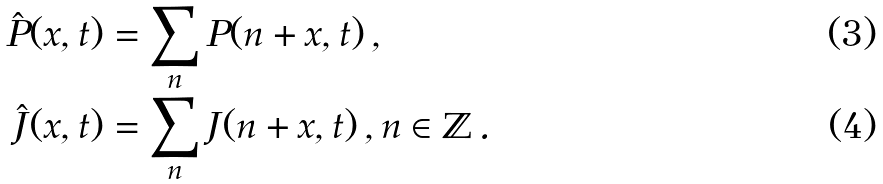Convert formula to latex. <formula><loc_0><loc_0><loc_500><loc_500>\hat { P } ( x , t ) & = \sum _ { n } P ( n + x , t ) \, , \\ \hat { J } ( x , t ) & = \sum _ { n } J ( n + x , t ) \, , n \in \mathbb { Z } \, .</formula> 